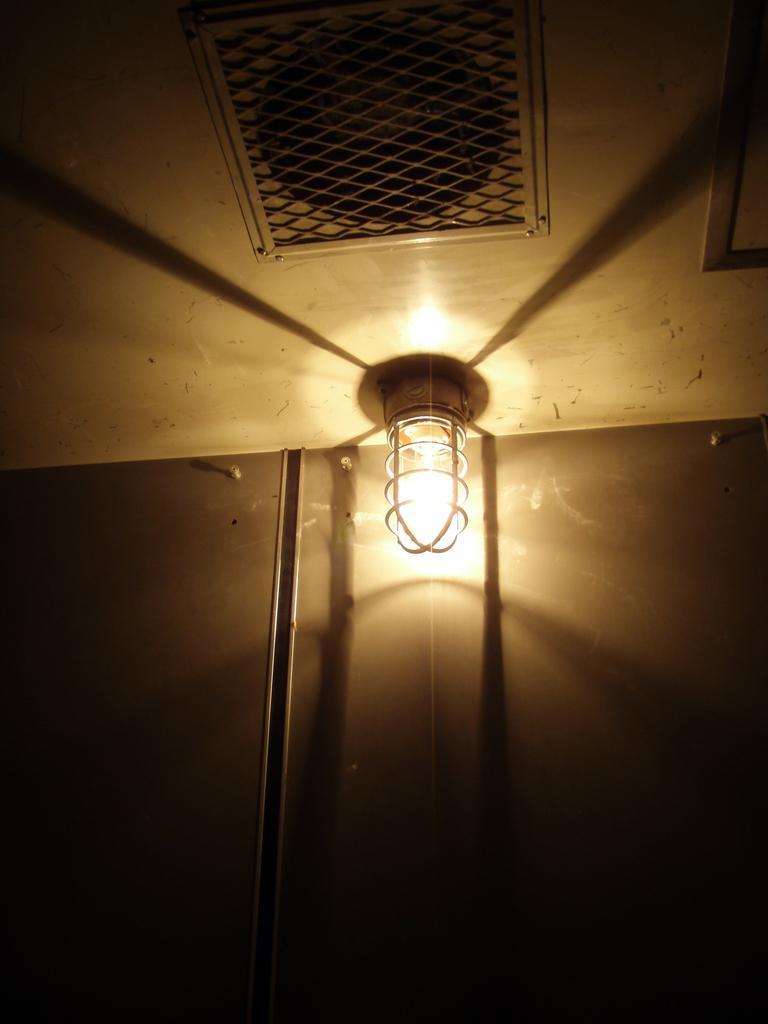Could you give a brief overview of what you see in this image? In this image there is a light and we can see a wall. At the top there is a mesh. 